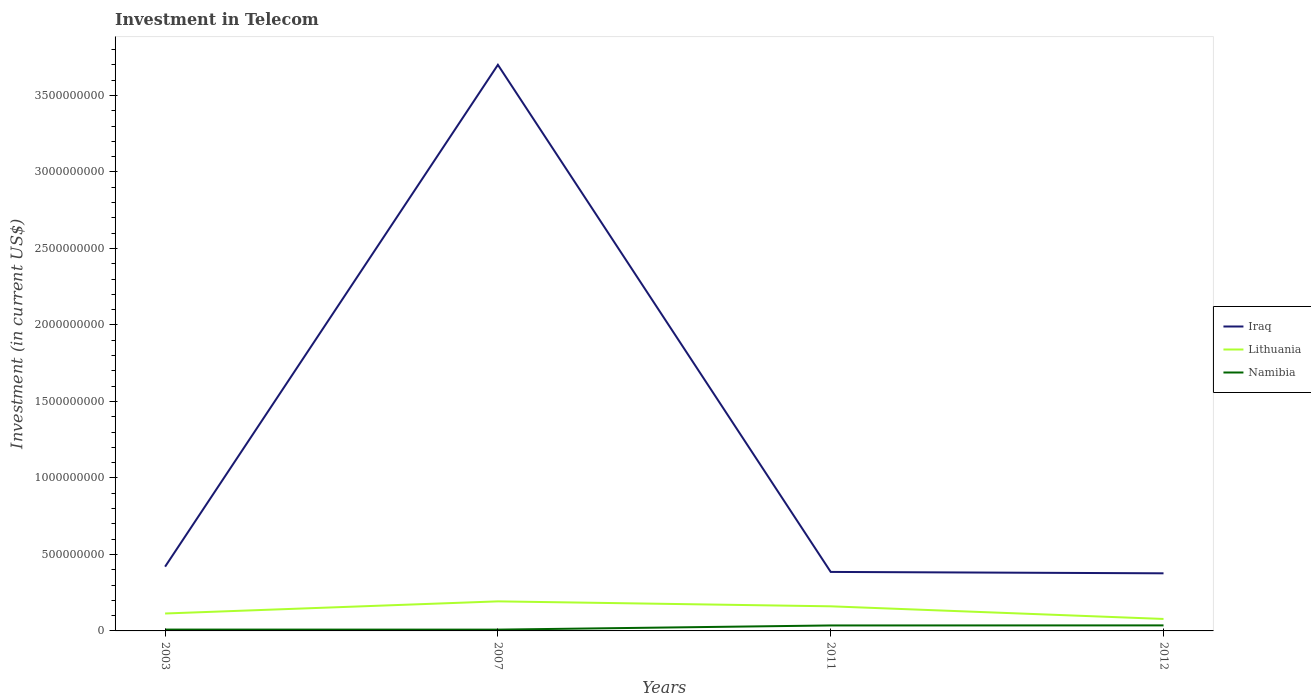Is the number of lines equal to the number of legend labels?
Your response must be concise. Yes. Across all years, what is the maximum amount invested in telecom in Namibia?
Provide a succinct answer. 8.50e+06. In which year was the amount invested in telecom in Iraq maximum?
Your answer should be compact. 2012. What is the total amount invested in telecom in Namibia in the graph?
Offer a terse response. -2.76e+07. What is the difference between the highest and the second highest amount invested in telecom in Namibia?
Offer a terse response. 2.76e+07. Is the amount invested in telecom in Lithuania strictly greater than the amount invested in telecom in Namibia over the years?
Offer a very short reply. No. What is the difference between two consecutive major ticks on the Y-axis?
Make the answer very short. 5.00e+08. Does the graph contain any zero values?
Keep it short and to the point. No. Does the graph contain grids?
Your response must be concise. No. Where does the legend appear in the graph?
Your answer should be very brief. Center right. How many legend labels are there?
Offer a very short reply. 3. How are the legend labels stacked?
Offer a very short reply. Vertical. What is the title of the graph?
Offer a very short reply. Investment in Telecom. Does "Small states" appear as one of the legend labels in the graph?
Ensure brevity in your answer.  No. What is the label or title of the X-axis?
Your response must be concise. Years. What is the label or title of the Y-axis?
Your answer should be compact. Investment (in current US$). What is the Investment (in current US$) of Iraq in 2003?
Offer a very short reply. 4.20e+08. What is the Investment (in current US$) in Lithuania in 2003?
Your answer should be very brief. 1.14e+08. What is the Investment (in current US$) of Namibia in 2003?
Your response must be concise. 8.75e+06. What is the Investment (in current US$) of Iraq in 2007?
Make the answer very short. 3.70e+09. What is the Investment (in current US$) of Lithuania in 2007?
Ensure brevity in your answer.  1.93e+08. What is the Investment (in current US$) of Namibia in 2007?
Your response must be concise. 8.50e+06. What is the Investment (in current US$) of Iraq in 2011?
Provide a short and direct response. 3.86e+08. What is the Investment (in current US$) in Lithuania in 2011?
Offer a very short reply. 1.61e+08. What is the Investment (in current US$) of Namibia in 2011?
Provide a succinct answer. 3.57e+07. What is the Investment (in current US$) in Iraq in 2012?
Your answer should be very brief. 3.76e+08. What is the Investment (in current US$) of Lithuania in 2012?
Provide a short and direct response. 7.82e+07. What is the Investment (in current US$) in Namibia in 2012?
Provide a short and direct response. 3.61e+07. Across all years, what is the maximum Investment (in current US$) in Iraq?
Make the answer very short. 3.70e+09. Across all years, what is the maximum Investment (in current US$) of Lithuania?
Offer a very short reply. 1.93e+08. Across all years, what is the maximum Investment (in current US$) in Namibia?
Provide a short and direct response. 3.61e+07. Across all years, what is the minimum Investment (in current US$) of Iraq?
Give a very brief answer. 3.76e+08. Across all years, what is the minimum Investment (in current US$) in Lithuania?
Make the answer very short. 7.82e+07. Across all years, what is the minimum Investment (in current US$) of Namibia?
Your answer should be very brief. 8.50e+06. What is the total Investment (in current US$) of Iraq in the graph?
Your response must be concise. 4.88e+09. What is the total Investment (in current US$) of Lithuania in the graph?
Your answer should be compact. 5.46e+08. What is the total Investment (in current US$) in Namibia in the graph?
Offer a very short reply. 8.90e+07. What is the difference between the Investment (in current US$) of Iraq in 2003 and that in 2007?
Give a very brief answer. -3.28e+09. What is the difference between the Investment (in current US$) in Lithuania in 2003 and that in 2007?
Offer a terse response. -7.93e+07. What is the difference between the Investment (in current US$) of Iraq in 2003 and that in 2011?
Your response must be concise. 3.44e+07. What is the difference between the Investment (in current US$) in Lithuania in 2003 and that in 2011?
Offer a very short reply. -4.69e+07. What is the difference between the Investment (in current US$) in Namibia in 2003 and that in 2011?
Your answer should be compact. -2.70e+07. What is the difference between the Investment (in current US$) in Iraq in 2003 and that in 2012?
Your answer should be very brief. 4.35e+07. What is the difference between the Investment (in current US$) of Lithuania in 2003 and that in 2012?
Your answer should be compact. 3.57e+07. What is the difference between the Investment (in current US$) in Namibia in 2003 and that in 2012?
Your response must be concise. -2.74e+07. What is the difference between the Investment (in current US$) of Iraq in 2007 and that in 2011?
Your response must be concise. 3.31e+09. What is the difference between the Investment (in current US$) in Lithuania in 2007 and that in 2011?
Provide a succinct answer. 3.24e+07. What is the difference between the Investment (in current US$) in Namibia in 2007 and that in 2011?
Provide a short and direct response. -2.72e+07. What is the difference between the Investment (in current US$) in Iraq in 2007 and that in 2012?
Offer a terse response. 3.32e+09. What is the difference between the Investment (in current US$) in Lithuania in 2007 and that in 2012?
Provide a succinct answer. 1.15e+08. What is the difference between the Investment (in current US$) of Namibia in 2007 and that in 2012?
Your answer should be very brief. -2.76e+07. What is the difference between the Investment (in current US$) of Iraq in 2011 and that in 2012?
Ensure brevity in your answer.  9.10e+06. What is the difference between the Investment (in current US$) in Lithuania in 2011 and that in 2012?
Ensure brevity in your answer.  8.26e+07. What is the difference between the Investment (in current US$) of Namibia in 2011 and that in 2012?
Your response must be concise. -4.00e+05. What is the difference between the Investment (in current US$) in Iraq in 2003 and the Investment (in current US$) in Lithuania in 2007?
Offer a very short reply. 2.27e+08. What is the difference between the Investment (in current US$) of Iraq in 2003 and the Investment (in current US$) of Namibia in 2007?
Your response must be concise. 4.12e+08. What is the difference between the Investment (in current US$) in Lithuania in 2003 and the Investment (in current US$) in Namibia in 2007?
Give a very brief answer. 1.05e+08. What is the difference between the Investment (in current US$) of Iraq in 2003 and the Investment (in current US$) of Lithuania in 2011?
Give a very brief answer. 2.59e+08. What is the difference between the Investment (in current US$) in Iraq in 2003 and the Investment (in current US$) in Namibia in 2011?
Offer a terse response. 3.84e+08. What is the difference between the Investment (in current US$) of Lithuania in 2003 and the Investment (in current US$) of Namibia in 2011?
Your answer should be very brief. 7.82e+07. What is the difference between the Investment (in current US$) in Iraq in 2003 and the Investment (in current US$) in Lithuania in 2012?
Your answer should be compact. 3.42e+08. What is the difference between the Investment (in current US$) of Iraq in 2003 and the Investment (in current US$) of Namibia in 2012?
Provide a short and direct response. 3.84e+08. What is the difference between the Investment (in current US$) in Lithuania in 2003 and the Investment (in current US$) in Namibia in 2012?
Ensure brevity in your answer.  7.78e+07. What is the difference between the Investment (in current US$) in Iraq in 2007 and the Investment (in current US$) in Lithuania in 2011?
Keep it short and to the point. 3.54e+09. What is the difference between the Investment (in current US$) in Iraq in 2007 and the Investment (in current US$) in Namibia in 2011?
Keep it short and to the point. 3.66e+09. What is the difference between the Investment (in current US$) in Lithuania in 2007 and the Investment (in current US$) in Namibia in 2011?
Your response must be concise. 1.58e+08. What is the difference between the Investment (in current US$) of Iraq in 2007 and the Investment (in current US$) of Lithuania in 2012?
Keep it short and to the point. 3.62e+09. What is the difference between the Investment (in current US$) in Iraq in 2007 and the Investment (in current US$) in Namibia in 2012?
Your answer should be very brief. 3.66e+09. What is the difference between the Investment (in current US$) in Lithuania in 2007 and the Investment (in current US$) in Namibia in 2012?
Offer a very short reply. 1.57e+08. What is the difference between the Investment (in current US$) in Iraq in 2011 and the Investment (in current US$) in Lithuania in 2012?
Provide a short and direct response. 3.07e+08. What is the difference between the Investment (in current US$) of Iraq in 2011 and the Investment (in current US$) of Namibia in 2012?
Provide a succinct answer. 3.50e+08. What is the difference between the Investment (in current US$) of Lithuania in 2011 and the Investment (in current US$) of Namibia in 2012?
Make the answer very short. 1.25e+08. What is the average Investment (in current US$) of Iraq per year?
Offer a very short reply. 1.22e+09. What is the average Investment (in current US$) of Lithuania per year?
Provide a short and direct response. 1.37e+08. What is the average Investment (in current US$) in Namibia per year?
Offer a very short reply. 2.23e+07. In the year 2003, what is the difference between the Investment (in current US$) of Iraq and Investment (in current US$) of Lithuania?
Ensure brevity in your answer.  3.06e+08. In the year 2003, what is the difference between the Investment (in current US$) in Iraq and Investment (in current US$) in Namibia?
Offer a very short reply. 4.11e+08. In the year 2003, what is the difference between the Investment (in current US$) of Lithuania and Investment (in current US$) of Namibia?
Provide a short and direct response. 1.05e+08. In the year 2007, what is the difference between the Investment (in current US$) in Iraq and Investment (in current US$) in Lithuania?
Provide a short and direct response. 3.51e+09. In the year 2007, what is the difference between the Investment (in current US$) in Iraq and Investment (in current US$) in Namibia?
Your response must be concise. 3.69e+09. In the year 2007, what is the difference between the Investment (in current US$) in Lithuania and Investment (in current US$) in Namibia?
Your answer should be very brief. 1.85e+08. In the year 2011, what is the difference between the Investment (in current US$) in Iraq and Investment (in current US$) in Lithuania?
Make the answer very short. 2.25e+08. In the year 2011, what is the difference between the Investment (in current US$) in Iraq and Investment (in current US$) in Namibia?
Provide a short and direct response. 3.50e+08. In the year 2011, what is the difference between the Investment (in current US$) of Lithuania and Investment (in current US$) of Namibia?
Provide a short and direct response. 1.25e+08. In the year 2012, what is the difference between the Investment (in current US$) of Iraq and Investment (in current US$) of Lithuania?
Make the answer very short. 2.98e+08. In the year 2012, what is the difference between the Investment (in current US$) of Iraq and Investment (in current US$) of Namibia?
Provide a short and direct response. 3.40e+08. In the year 2012, what is the difference between the Investment (in current US$) of Lithuania and Investment (in current US$) of Namibia?
Your response must be concise. 4.21e+07. What is the ratio of the Investment (in current US$) in Iraq in 2003 to that in 2007?
Your answer should be very brief. 0.11. What is the ratio of the Investment (in current US$) in Lithuania in 2003 to that in 2007?
Provide a succinct answer. 0.59. What is the ratio of the Investment (in current US$) of Namibia in 2003 to that in 2007?
Make the answer very short. 1.03. What is the ratio of the Investment (in current US$) in Iraq in 2003 to that in 2011?
Your answer should be very brief. 1.09. What is the ratio of the Investment (in current US$) of Lithuania in 2003 to that in 2011?
Provide a succinct answer. 0.71. What is the ratio of the Investment (in current US$) in Namibia in 2003 to that in 2011?
Keep it short and to the point. 0.25. What is the ratio of the Investment (in current US$) in Iraq in 2003 to that in 2012?
Make the answer very short. 1.12. What is the ratio of the Investment (in current US$) in Lithuania in 2003 to that in 2012?
Offer a very short reply. 1.46. What is the ratio of the Investment (in current US$) of Namibia in 2003 to that in 2012?
Your response must be concise. 0.24. What is the ratio of the Investment (in current US$) of Iraq in 2007 to that in 2011?
Give a very brief answer. 9.6. What is the ratio of the Investment (in current US$) in Lithuania in 2007 to that in 2011?
Provide a short and direct response. 1.2. What is the ratio of the Investment (in current US$) in Namibia in 2007 to that in 2011?
Offer a very short reply. 0.24. What is the ratio of the Investment (in current US$) in Iraq in 2007 to that in 2012?
Offer a terse response. 9.83. What is the ratio of the Investment (in current US$) of Lithuania in 2007 to that in 2012?
Give a very brief answer. 2.47. What is the ratio of the Investment (in current US$) in Namibia in 2007 to that in 2012?
Your answer should be compact. 0.24. What is the ratio of the Investment (in current US$) of Iraq in 2011 to that in 2012?
Keep it short and to the point. 1.02. What is the ratio of the Investment (in current US$) in Lithuania in 2011 to that in 2012?
Provide a succinct answer. 2.06. What is the ratio of the Investment (in current US$) of Namibia in 2011 to that in 2012?
Provide a short and direct response. 0.99. What is the difference between the highest and the second highest Investment (in current US$) in Iraq?
Provide a short and direct response. 3.28e+09. What is the difference between the highest and the second highest Investment (in current US$) in Lithuania?
Keep it short and to the point. 3.24e+07. What is the difference between the highest and the lowest Investment (in current US$) of Iraq?
Your answer should be very brief. 3.32e+09. What is the difference between the highest and the lowest Investment (in current US$) in Lithuania?
Provide a short and direct response. 1.15e+08. What is the difference between the highest and the lowest Investment (in current US$) of Namibia?
Offer a terse response. 2.76e+07. 